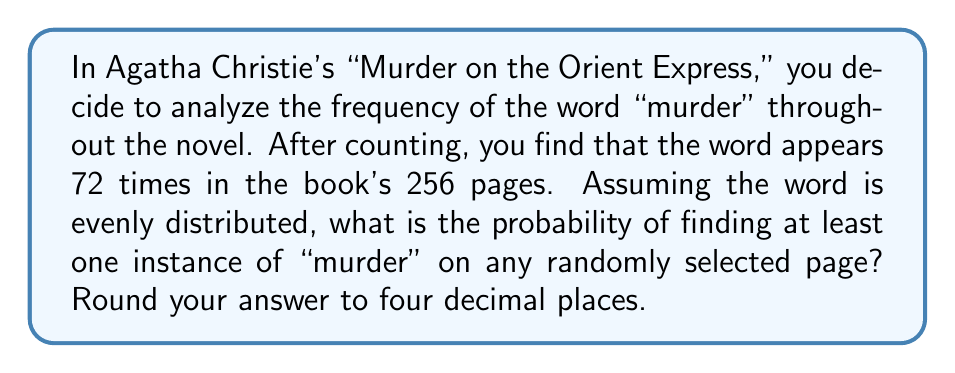Provide a solution to this math problem. Let's approach this step-by-step:

1) First, we need to calculate the average number of times "murder" appears per page:
   $\lambda = \frac{72 \text{ occurrences}}{256 \text{ pages}} = 0.28125$ occurrences per page

2) Now, we want to find the probability of at least one occurrence on a random page. This is easier to calculate by first finding the probability of no occurrences and then subtracting from 1.

3) The probability of a certain number of occurrences on a page follows a Poisson distribution. The probability of exactly $k$ occurrences is given by:

   $$P(X=k) = \frac{e^{-\lambda}\lambda^k}{k!}$$

4) For no occurrences $(k=0)$, this becomes:

   $$P(X=0) = \frac{e^{-\lambda}\lambda^0}{0!} = e^{-\lambda}$$

5) Substituting our $\lambda$ value:

   $$P(X=0) = e^{-0.28125} \approx 0.7548$$

6) Therefore, the probability of at least one occurrence is:

   $$P(X \geq 1) = 1 - P(X=0) = 1 - 0.7548 \approx 0.2452$$

7) Rounding to four decimal places: 0.2452
Answer: 0.2452 